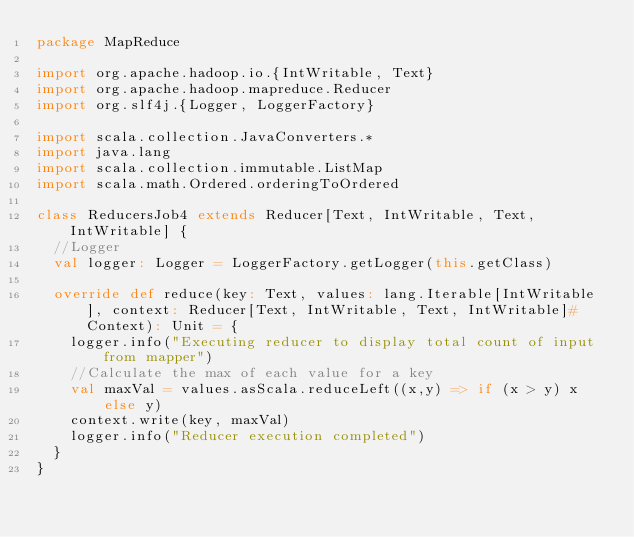<code> <loc_0><loc_0><loc_500><loc_500><_Scala_>package MapReduce

import org.apache.hadoop.io.{IntWritable, Text}
import org.apache.hadoop.mapreduce.Reducer
import org.slf4j.{Logger, LoggerFactory}

import scala.collection.JavaConverters.*
import java.lang
import scala.collection.immutable.ListMap
import scala.math.Ordered.orderingToOrdered

class ReducersJob4 extends Reducer[Text, IntWritable, Text, IntWritable] {
  //Logger
  val logger: Logger = LoggerFactory.getLogger(this.getClass)

  override def reduce(key: Text, values: lang.Iterable[IntWritable], context: Reducer[Text, IntWritable, Text, IntWritable]#Context): Unit = {
    logger.info("Executing reducer to display total count of input from mapper")
    //Calculate the max of each value for a key
    val maxVal = values.asScala.reduceLeft((x,y) => if (x > y) x else y)
    context.write(key, maxVal)
    logger.info("Reducer execution completed")
  }
}
</code> 